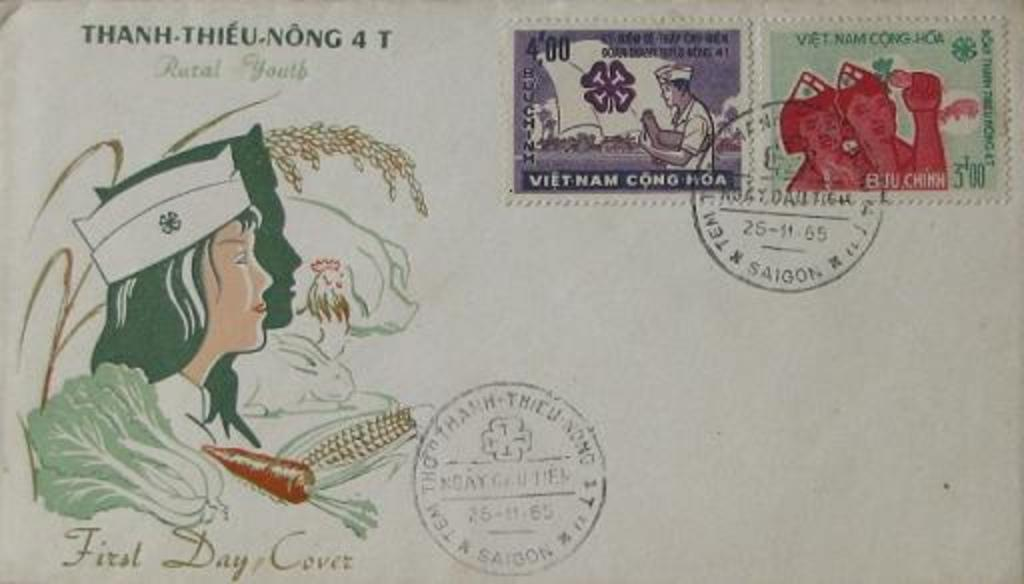<image>
Provide a brief description of the given image. A postcard eith Vietnamese postage stamps is dated 25-11-65. 